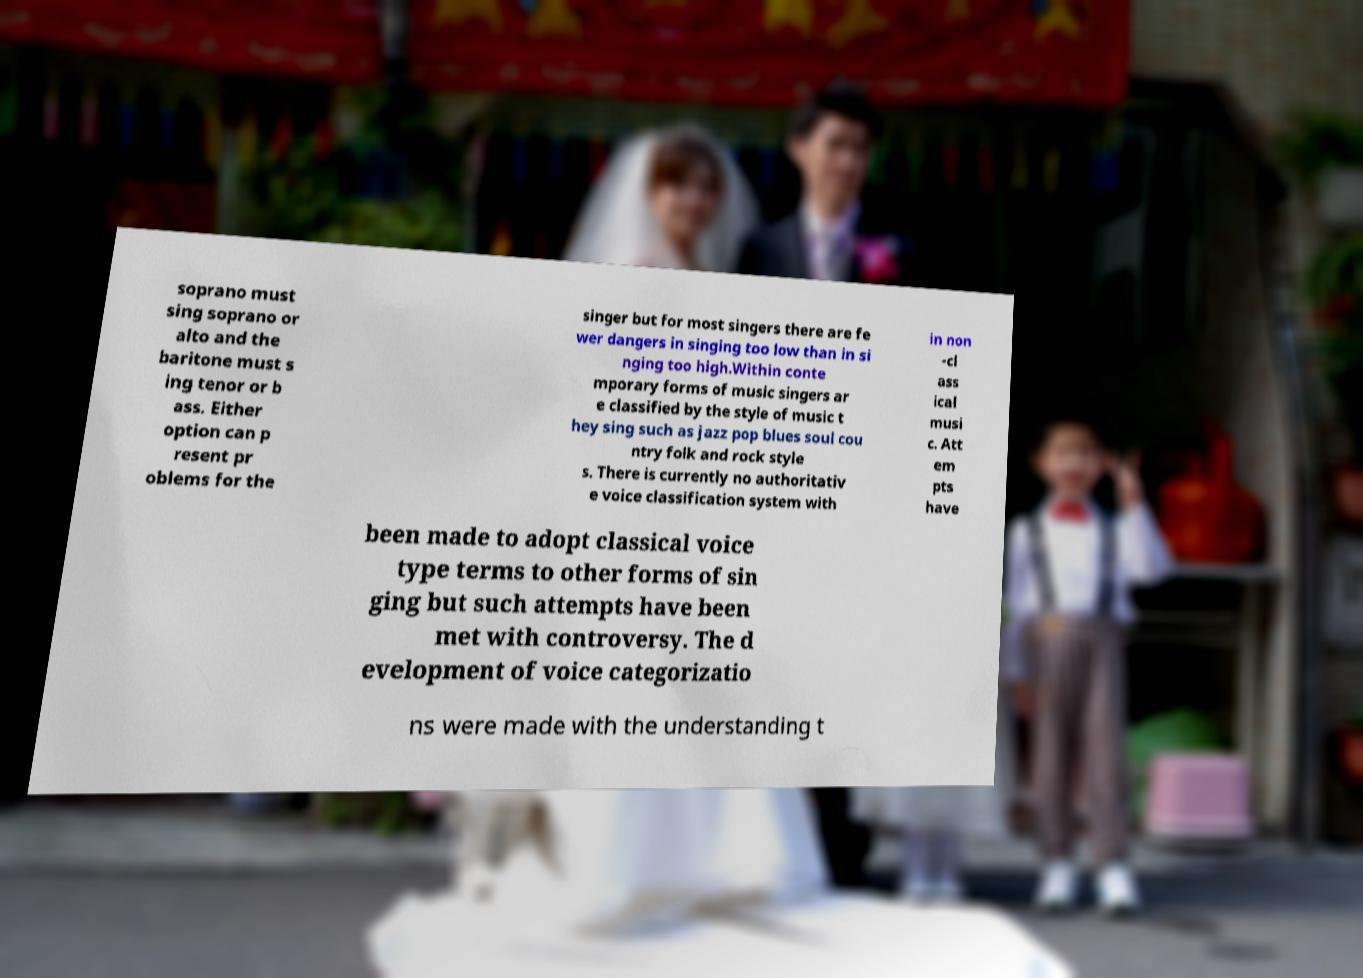Can you read and provide the text displayed in the image?This photo seems to have some interesting text. Can you extract and type it out for me? soprano must sing soprano or alto and the baritone must s ing tenor or b ass. Either option can p resent pr oblems for the singer but for most singers there are fe wer dangers in singing too low than in si nging too high.Within conte mporary forms of music singers ar e classified by the style of music t hey sing such as jazz pop blues soul cou ntry folk and rock style s. There is currently no authoritativ e voice classification system with in non -cl ass ical musi c. Att em pts have been made to adopt classical voice type terms to other forms of sin ging but such attempts have been met with controversy. The d evelopment of voice categorizatio ns were made with the understanding t 